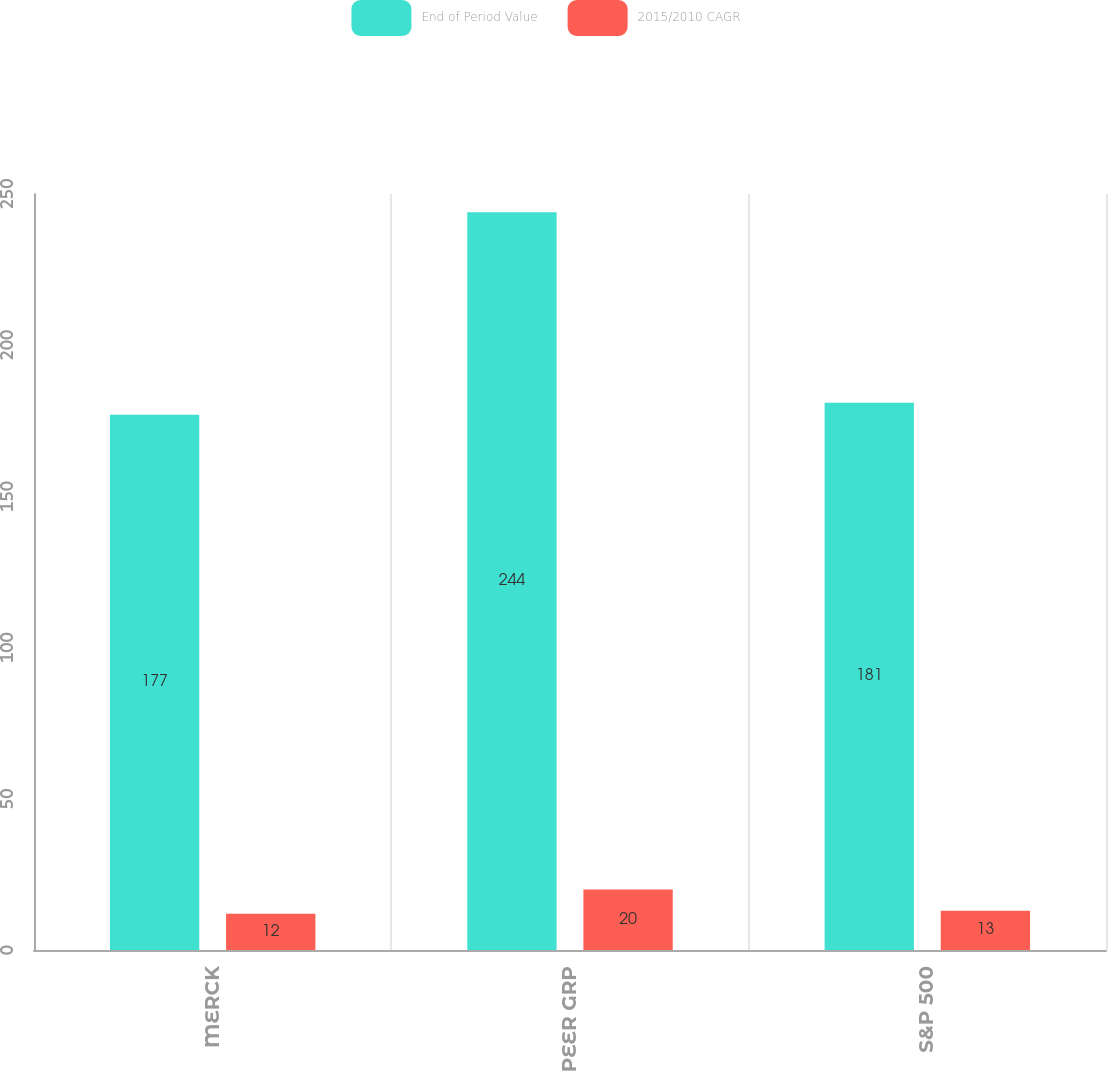Convert chart to OTSL. <chart><loc_0><loc_0><loc_500><loc_500><stacked_bar_chart><ecel><fcel>MERCK<fcel>PEER GRP<fcel>S&P 500<nl><fcel>End of Period Value<fcel>177<fcel>244<fcel>181<nl><fcel>2015/2010 CAGR<fcel>12<fcel>20<fcel>13<nl></chart> 